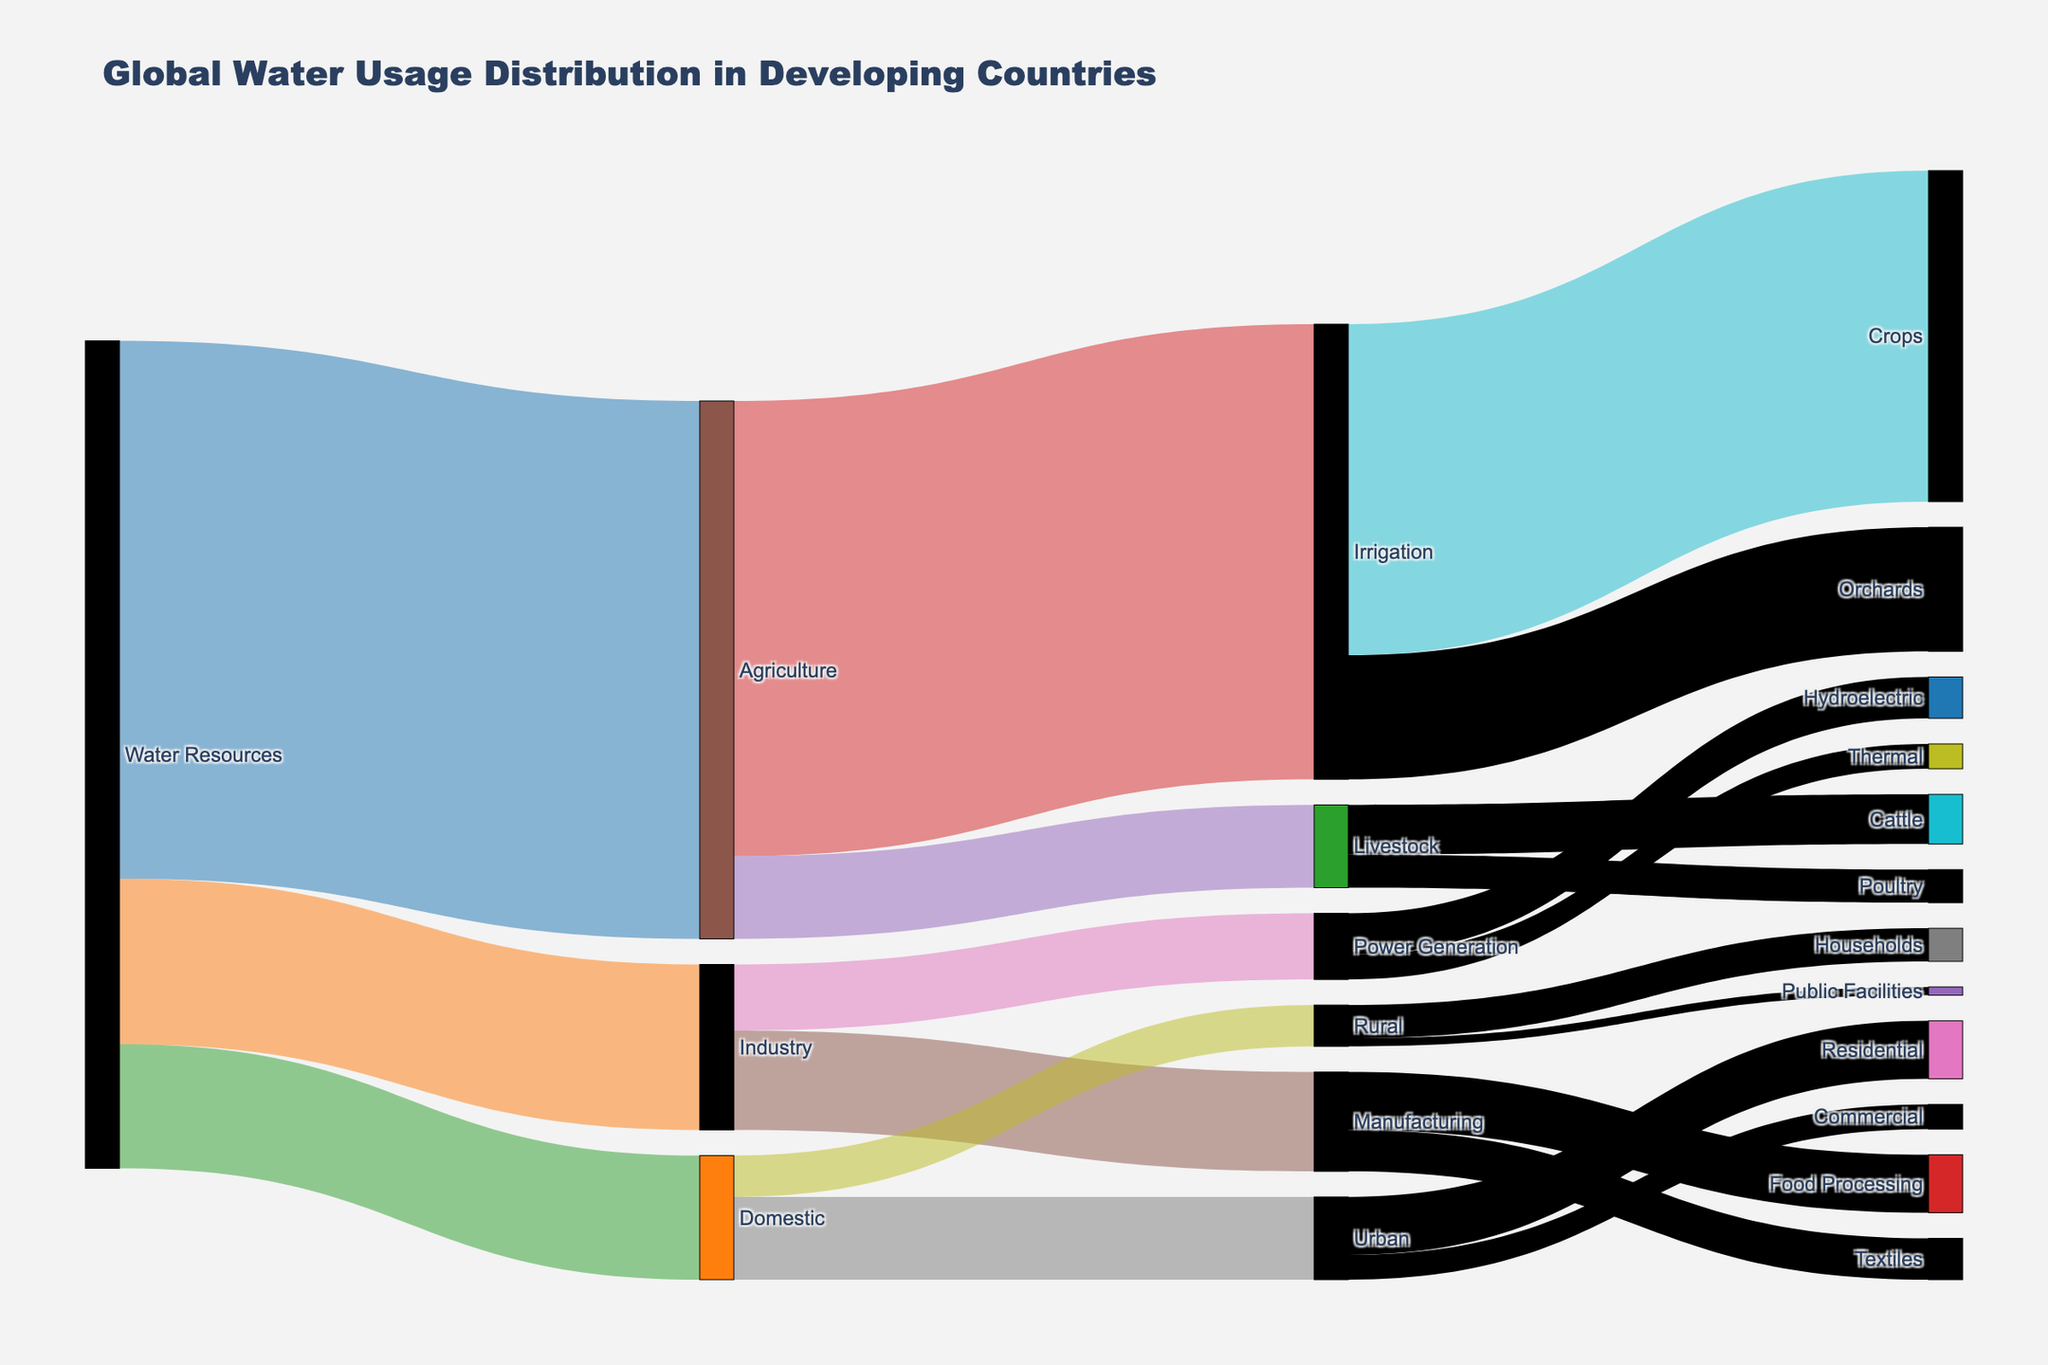How many main water resource categories are there in the diagram? The diagram shows lines originating from nodes representing main water resource categories. These nodes are labeled 'Water Resources'.
Answer: 1 Name the sectors where the 'Agriculture' node directs water resources. The diagram indicates arrows moving from 'Agriculture' to two sectors labeled 'Irrigation' and 'Livestock'.
Answer: Irrigation, Livestock What is the total percentage of water used by 'Domestic' and 'Industry' combined? According to the diagram, 'Domestic' uses 15% and 'Industry' uses 20% of the water resources. Adding these gives 15 + 20.
Answer: 35% Which sector uses more water: 'Urban' or 'Rural'? By looking at the values directed from 'Domestic' to 'Urban' and 'Rural,' we see 'Urban' uses 10% and 'Rural' uses 5% of water. Comparing these values shows 'Urban' uses more.
Answer: Urban Where does the majority of water directed to 'Power Generation' go? Inspecting the flows from 'Power Generation,' we see two arrows leading to 'Hydroelectric' and 'Thermal'. 'Hydroelectric' has a larger value of 5 compared to 'Thermal' with 3.
Answer: Hydroelectric Calculate the total water percentage used by 'Crops' and 'Orchards'. The 'Irrigation' node directs water to 'Crops' (40%) and 'Orchards' (15%). Summing these values gives 40 + 15.
Answer: 55% Which node has the highest number of outgoing links? In the diagram, the 'Agriculture' node directs water to two nodes ('Irrigation' and 'Livestock'), indicating the highest number of outgoing links.
Answer: Agriculture How much water does 'Manufacturing' consume within the 'Industry' sector? Checking the flow from 'Industry' to 'Manufacturing,' the diagram shows 12% of water use is in 'Manufacturing'.
Answer: 12% Compare the water usage between 'Textiles' and 'Food Processing' within 'Manufacturing'. 'Textiles' uses 5% of water and 'Food Processing' uses 7%, shown by the directed lines from 'Manufacturing'. 'Food Processing' uses more water.
Answer: Food Processing What percentage of water resources is not directly used by 'Agriculture'? The total water resources are 100%. 'Agriculture' uses 65% of water resources. The remaining percentage is 100 - 65.
Answer: 35% 